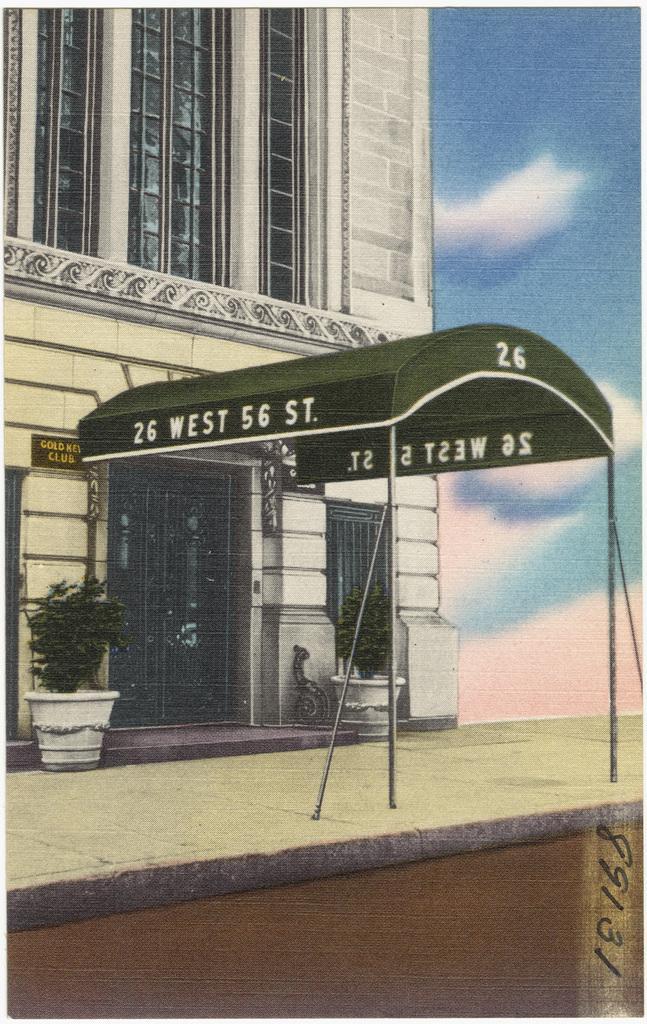In one or two sentences, can you explain what this image depicts? In this picture we can see a paper and on the paper there is a building and house plants. Behind the building there is a sky. 